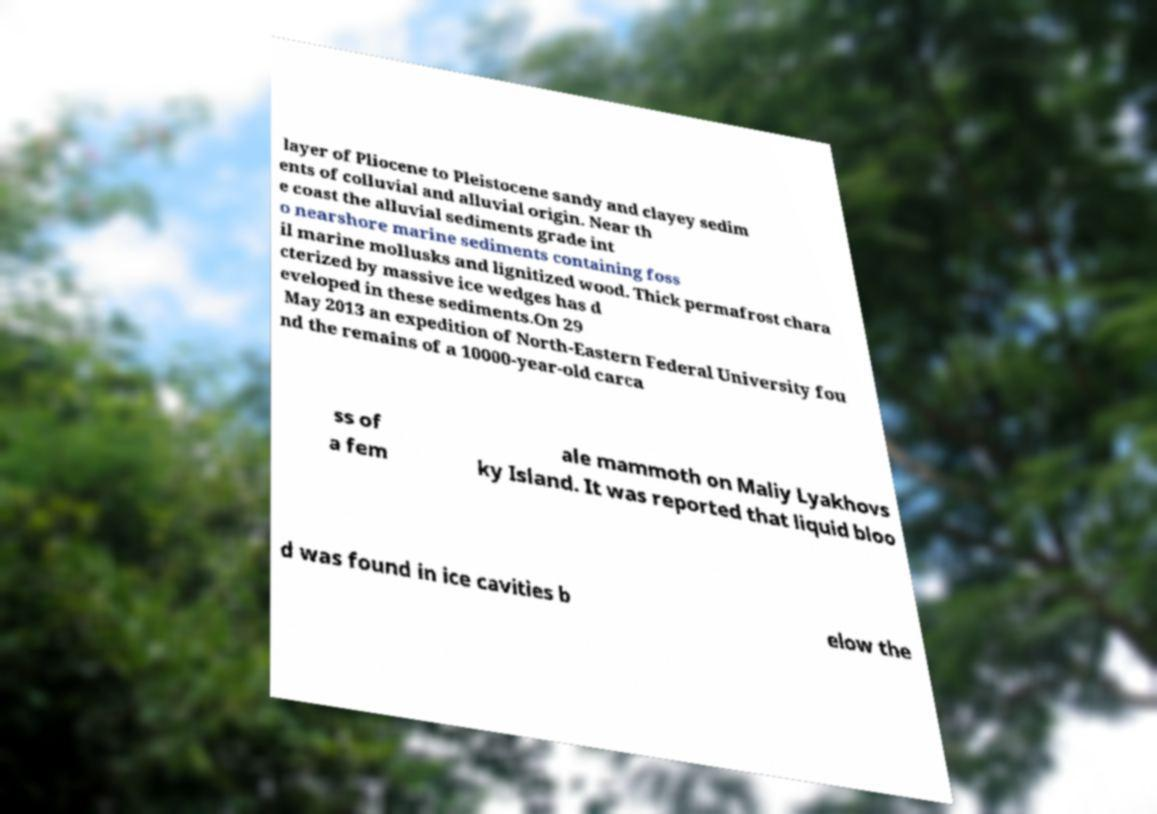Please identify and transcribe the text found in this image. layer of Pliocene to Pleistocene sandy and clayey sedim ents of colluvial and alluvial origin. Near th e coast the alluvial sediments grade int o nearshore marine sediments containing foss il marine mollusks and lignitized wood. Thick permafrost chara cterized by massive ice wedges has d eveloped in these sediments.On 29 May 2013 an expedition of North-Eastern Federal University fou nd the remains of a 10000-year-old carca ss of a fem ale mammoth on Maliy Lyakhovs ky Island. It was reported that liquid bloo d was found in ice cavities b elow the 